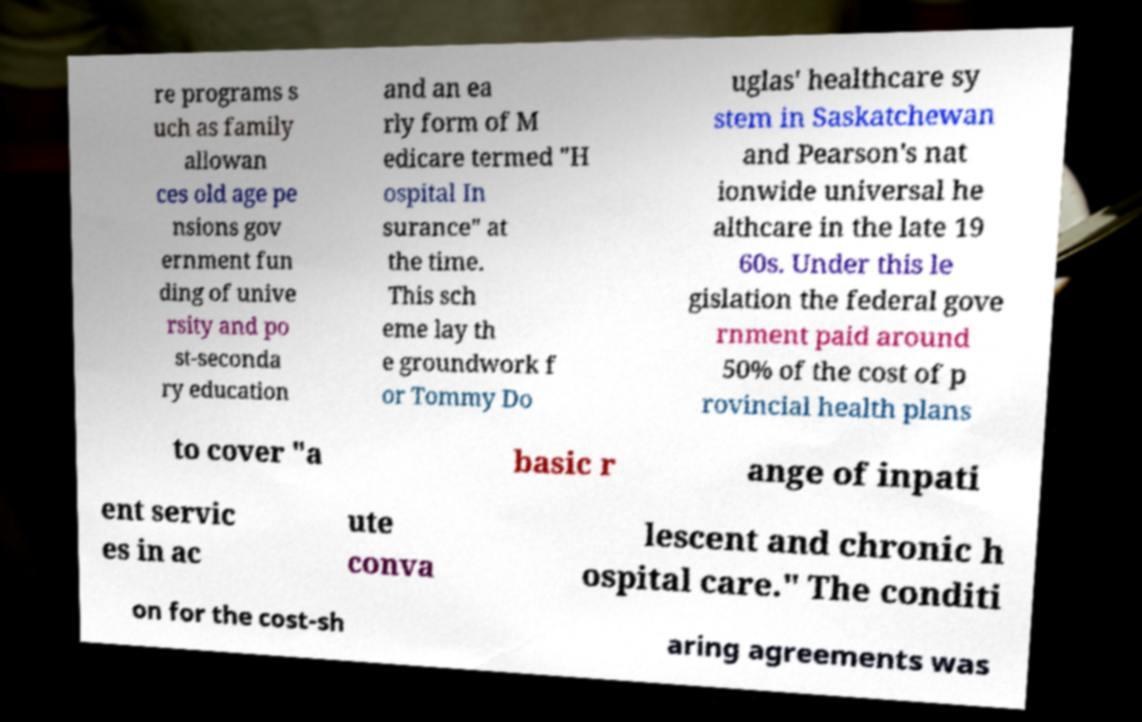Can you read and provide the text displayed in the image?This photo seems to have some interesting text. Can you extract and type it out for me? re programs s uch as family allowan ces old age pe nsions gov ernment fun ding of unive rsity and po st-seconda ry education and an ea rly form of M edicare termed "H ospital In surance" at the time. This sch eme lay th e groundwork f or Tommy Do uglas' healthcare sy stem in Saskatchewan and Pearson's nat ionwide universal he althcare in the late 19 60s. Under this le gislation the federal gove rnment paid around 50% of the cost of p rovincial health plans to cover "a basic r ange of inpati ent servic es in ac ute conva lescent and chronic h ospital care." The conditi on for the cost-sh aring agreements was 